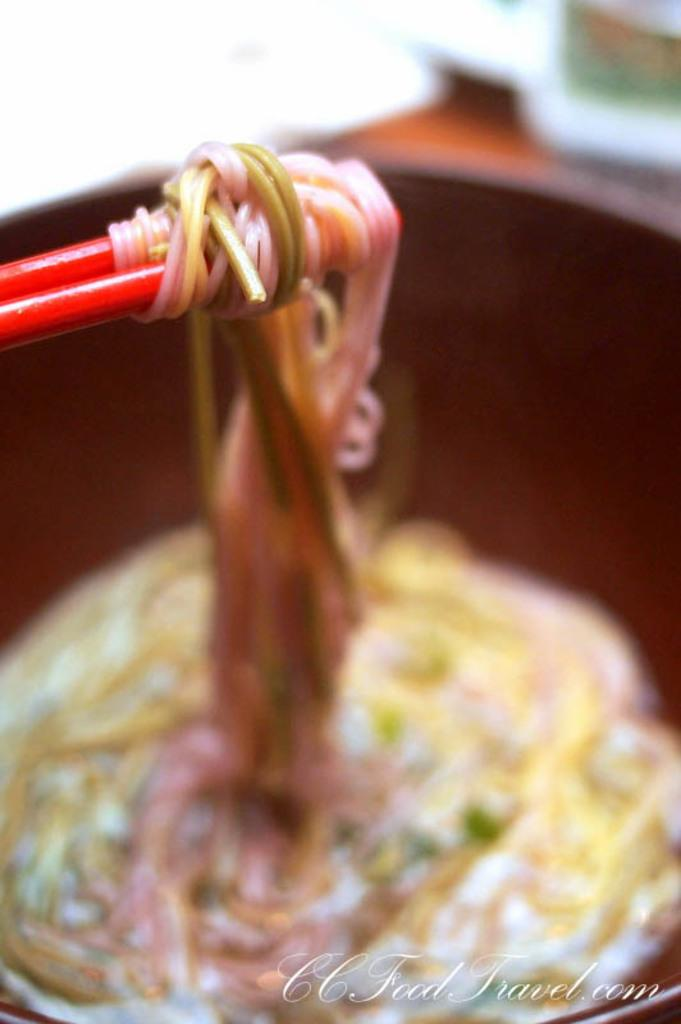What type of food is being eaten with chopsticks in the image? There are chopsticks with noodles in the image. What is the container for the noodles? There is a bowl with noodles in the image. Can you describe the background of the image? The background of the image is blurred. Is there any text visible in the image? Yes, there is text in the right bottom corner of the image. What time of day is it in the image, considering the presence of a pin and a ball? There is no pin or ball present in the image, so it is not possible to determine the time of day based on these objects. 